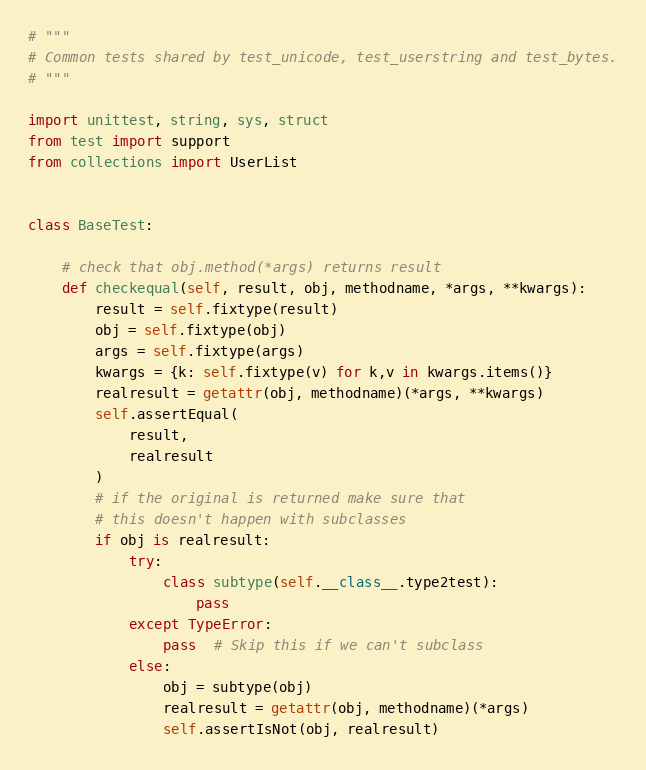<code> <loc_0><loc_0><loc_500><loc_500><_Python_># """
# Common tests shared by test_unicode, test_userstring and test_bytes.
# """

import unittest, string, sys, struct
from test import support
from collections import UserList


class BaseTest:

    # check that obj.method(*args) returns result
    def checkequal(self, result, obj, methodname, *args, **kwargs):
        result = self.fixtype(result)
        obj = self.fixtype(obj)
        args = self.fixtype(args)
        kwargs = {k: self.fixtype(v) for k,v in kwargs.items()}
        realresult = getattr(obj, methodname)(*args, **kwargs)
        self.assertEqual(
            result,
            realresult
        )
        # if the original is returned make sure that
        # this doesn't happen with subclasses
        if obj is realresult:
            try:
                class subtype(self.__class__.type2test):
                    pass
            except TypeError:
                pass  # Skip this if we can't subclass
            else:
                obj = subtype(obj)
                realresult = getattr(obj, methodname)(*args)
                self.assertIsNot(obj, realresult)
</code> 